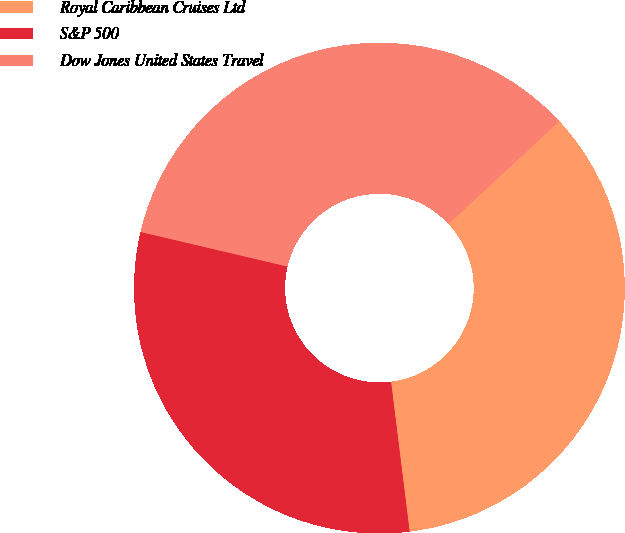Convert chart. <chart><loc_0><loc_0><loc_500><loc_500><pie_chart><fcel>Royal Caribbean Cruises Ltd<fcel>S&P 500<fcel>Dow Jones United States Travel<nl><fcel>34.94%<fcel>30.64%<fcel>34.41%<nl></chart> 